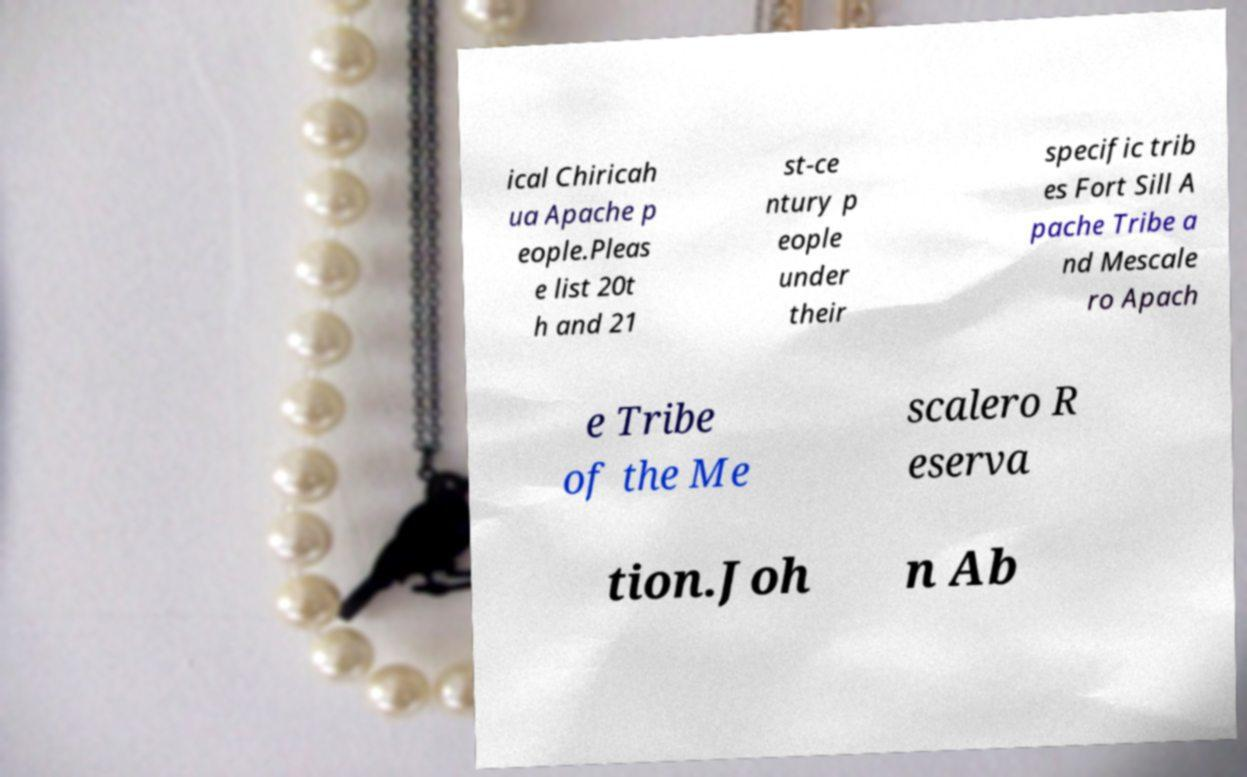Can you accurately transcribe the text from the provided image for me? ical Chiricah ua Apache p eople.Pleas e list 20t h and 21 st-ce ntury p eople under their specific trib es Fort Sill A pache Tribe a nd Mescale ro Apach e Tribe of the Me scalero R eserva tion.Joh n Ab 